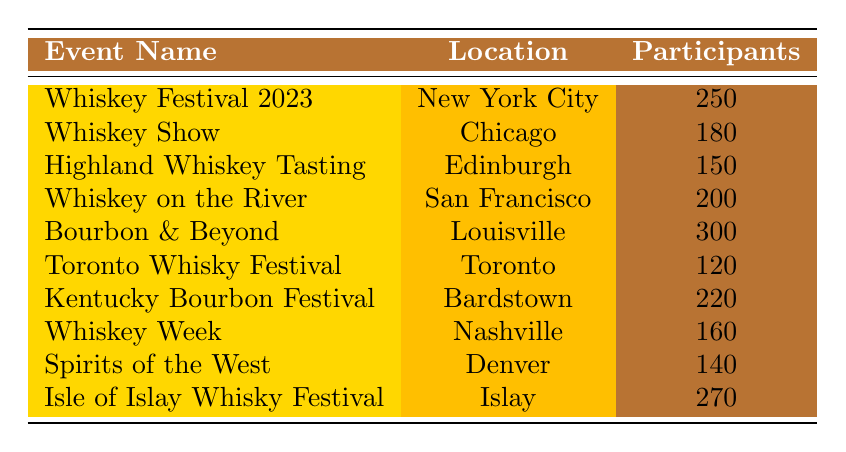What is the name of the event with the highest number of participants? By reviewing the participant counts listed in the table, I can see that "Bourbon & Beyond" has the highest participant count of 300.
Answer: Bourbon & Beyond How many participants attended the "Whiskey on the River" event? The table shows that the "Whiskey on the River" event had 200 participants.
Answer: 200 Is there an event held in Nashville? The table indicates that "Whiskey Week" is an event that took place in Nashville, confirming that yes, there is an event held in that location.
Answer: Yes What is the total number of participants for the events held in September? The events in September are "Bourbon & Beyond" with 300 participants and "Kentucky Bourbon Festival" with 220 participants. Adding these gives 300 + 220 = 520.
Answer: 520 Which event had more participants: "Spirits of the West" or "Highland Whiskey Tasting"? "Spirits of the West" had 140 participants, while "Highland Whiskey Tasting" had 150 participants. Since 150 is greater than 140, "Highland Whiskey Tasting" had more participants.
Answer: Highland Whiskey Tasting What is the average number of participants for all the events listed? To find the average, I sum the participant counts: (250 + 180 + 150 + 200 + 300 + 120 + 220 + 160 + 140 + 270) = 1990. There are 10 events, so the average is 1990 / 10 = 199.
Answer: 199 How many events had more than 200 participants? The events with more than 200 participants are "Bourbon & Beyond" (300), "Isle of Islay Whisky Festival" (270), and "Kentucky Bourbon Festival" (220). This totals 3 events.
Answer: 3 What is the difference in participants between the least and most attended events? The least attended event is "Toronto Whisky Festival" with 120 participants, and the most attended is "Bourbon & Beyond" with 300 participants. The difference is 300 - 120 = 180.
Answer: 180 Which location hosted the "Isle of Islay Whisky Festival"? The table specifies that "Isle of Islay Whisky Festival" was hosted in Islay.
Answer: Islay 